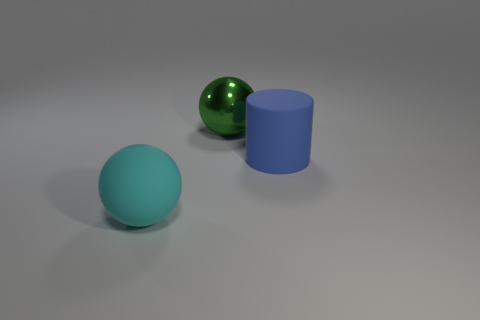Add 1 large green things. How many objects exist? 4 Subtract all cylinders. How many objects are left? 2 Subtract all small brown matte objects. Subtract all spheres. How many objects are left? 1 Add 3 cyan rubber objects. How many cyan rubber objects are left? 4 Add 3 large cyan balls. How many large cyan balls exist? 4 Subtract 0 gray cubes. How many objects are left? 3 